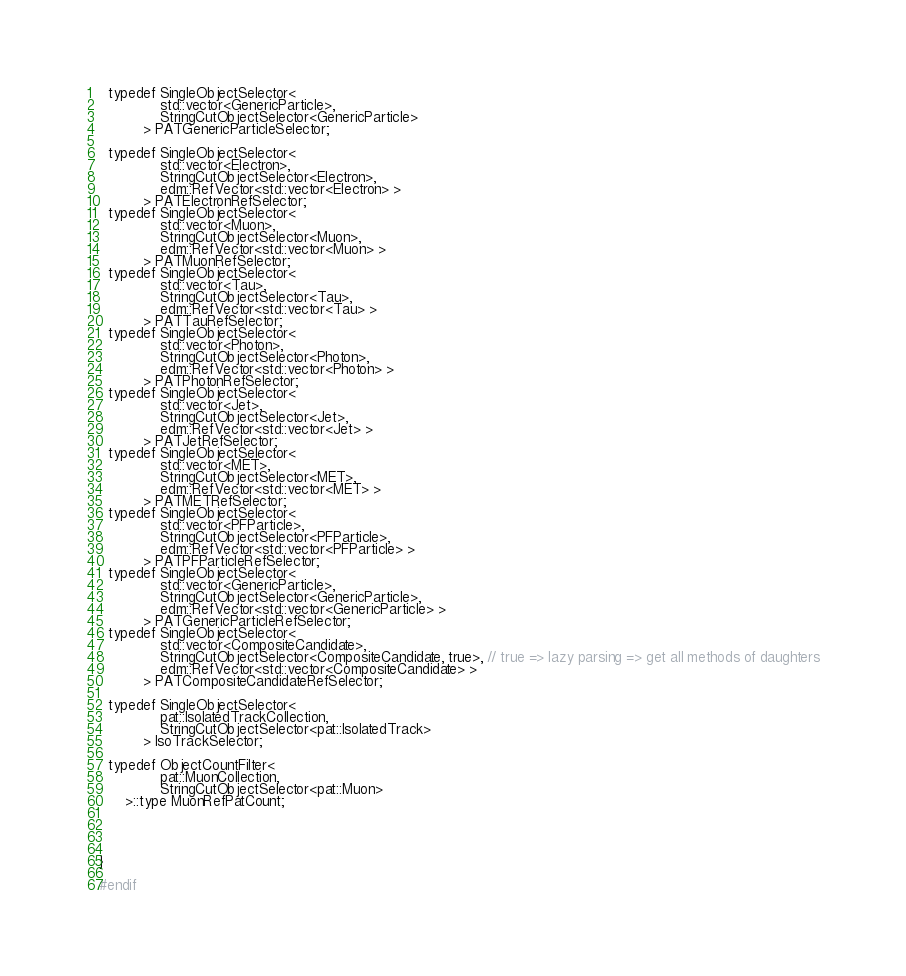Convert code to text. <code><loc_0><loc_0><loc_500><loc_500><_C_>  typedef SingleObjectSelector<
              std::vector<GenericParticle>,
              StringCutObjectSelector<GenericParticle>
          > PATGenericParticleSelector;

  typedef SingleObjectSelector<
              std::vector<Electron>,
              StringCutObjectSelector<Electron>,
              edm::RefVector<std::vector<Electron> >
          > PATElectronRefSelector;
  typedef SingleObjectSelector<
              std::vector<Muon>,
              StringCutObjectSelector<Muon>,
              edm::RefVector<std::vector<Muon> >
          > PATMuonRefSelector;
  typedef SingleObjectSelector<
              std::vector<Tau>,
              StringCutObjectSelector<Tau>,
              edm::RefVector<std::vector<Tau> >
          > PATTauRefSelector;
  typedef SingleObjectSelector<
              std::vector<Photon>,
              StringCutObjectSelector<Photon>,
              edm::RefVector<std::vector<Photon> >
          > PATPhotonRefSelector;
  typedef SingleObjectSelector<
              std::vector<Jet>,
              StringCutObjectSelector<Jet>,
              edm::RefVector<std::vector<Jet> >
          > PATJetRefSelector;
  typedef SingleObjectSelector<
              std::vector<MET>,
              StringCutObjectSelector<MET>,
              edm::RefVector<std::vector<MET> >
          > PATMETRefSelector;
  typedef SingleObjectSelector<
              std::vector<PFParticle>,
              StringCutObjectSelector<PFParticle>,
              edm::RefVector<std::vector<PFParticle> >
          > PATPFParticleRefSelector;
  typedef SingleObjectSelector<
              std::vector<GenericParticle>,
              StringCutObjectSelector<GenericParticle>,
              edm::RefVector<std::vector<GenericParticle> >
          > PATGenericParticleRefSelector;
  typedef SingleObjectSelector<
              std::vector<CompositeCandidate>,
              StringCutObjectSelector<CompositeCandidate, true>, // true => lazy parsing => get all methods of daughters
              edm::RefVector<std::vector<CompositeCandidate> >
          > PATCompositeCandidateRefSelector;

  typedef SingleObjectSelector<
              pat::IsolatedTrackCollection, 
              StringCutObjectSelector<pat::IsolatedTrack> 
          > IsoTrackSelector;

  typedef ObjectCountFilter<
              pat::MuonCollection, 
              StringCutObjectSelector<pat::Muon>
	  >::type MuonRefPatCount;




}

#endif
</code> 